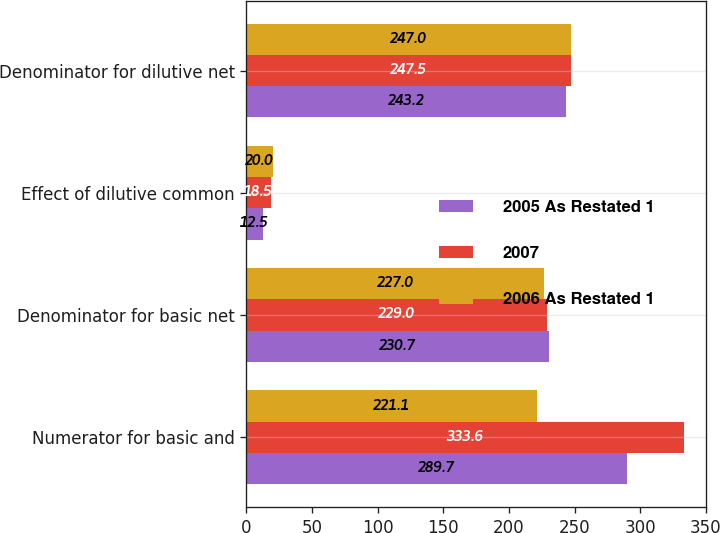Convert chart to OTSL. <chart><loc_0><loc_0><loc_500><loc_500><stacked_bar_chart><ecel><fcel>Numerator for basic and<fcel>Denominator for basic net<fcel>Effect of dilutive common<fcel>Denominator for dilutive net<nl><fcel>2005 As Restated 1<fcel>289.7<fcel>230.7<fcel>12.5<fcel>243.2<nl><fcel>2007<fcel>333.6<fcel>229<fcel>18.5<fcel>247.5<nl><fcel>2006 As Restated 1<fcel>221.1<fcel>227<fcel>20<fcel>247<nl></chart> 